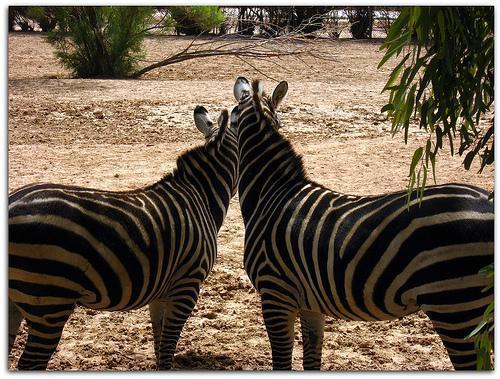How many zebras are there?
Give a very brief answer. 2. How many people have stripped shirts?
Give a very brief answer. 0. 